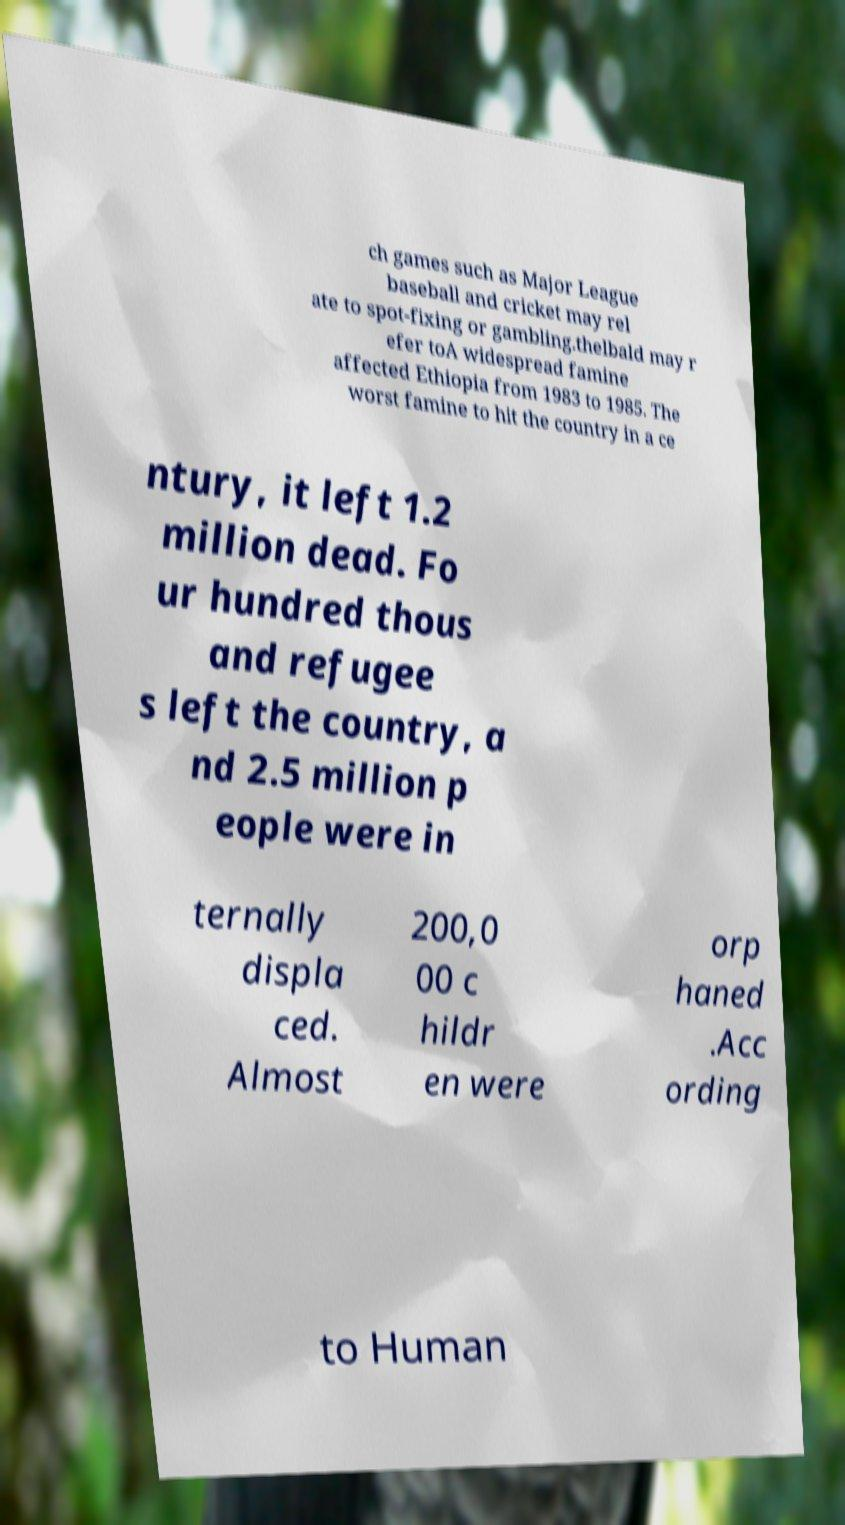I need the written content from this picture converted into text. Can you do that? ch games such as Major League baseball and cricket may rel ate to spot-fixing or gambling.thelbald may r efer toA widespread famine affected Ethiopia from 1983 to 1985. The worst famine to hit the country in a ce ntury, it left 1.2 million dead. Fo ur hundred thous and refugee s left the country, a nd 2.5 million p eople were in ternally displa ced. Almost 200,0 00 c hildr en were orp haned .Acc ording to Human 